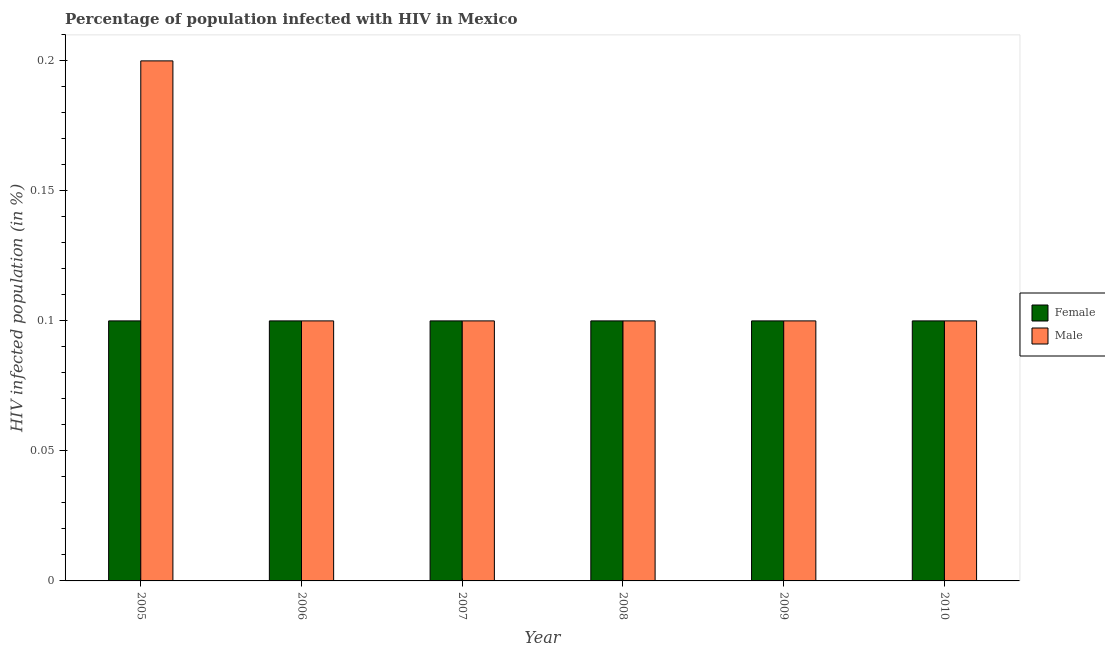How many different coloured bars are there?
Make the answer very short. 2. How many bars are there on the 5th tick from the right?
Your answer should be compact. 2. What is the label of the 6th group of bars from the left?
Ensure brevity in your answer.  2010. In how many cases, is the number of bars for a given year not equal to the number of legend labels?
Your answer should be compact. 0. What is the percentage of females who are infected with hiv in 2007?
Provide a succinct answer. 0.1. In which year was the percentage of females who are infected with hiv maximum?
Offer a terse response. 2005. In which year was the percentage of females who are infected with hiv minimum?
Offer a very short reply. 2005. What is the total percentage of males who are infected with hiv in the graph?
Offer a very short reply. 0.7. What is the difference between the percentage of females who are infected with hiv in 2008 and the percentage of males who are infected with hiv in 2009?
Ensure brevity in your answer.  0. What is the average percentage of females who are infected with hiv per year?
Provide a succinct answer. 0.1. Is the percentage of males who are infected with hiv in 2007 less than that in 2008?
Your response must be concise. No. Is the difference between the percentage of males who are infected with hiv in 2005 and 2006 greater than the difference between the percentage of females who are infected with hiv in 2005 and 2006?
Your answer should be very brief. No. What does the 2nd bar from the right in 2009 represents?
Give a very brief answer. Female. Does the graph contain any zero values?
Offer a very short reply. No. How many legend labels are there?
Offer a very short reply. 2. How are the legend labels stacked?
Your answer should be very brief. Vertical. What is the title of the graph?
Your answer should be very brief. Percentage of population infected with HIV in Mexico. What is the label or title of the Y-axis?
Provide a succinct answer. HIV infected population (in %). What is the HIV infected population (in %) of Female in 2005?
Keep it short and to the point. 0.1. What is the HIV infected population (in %) in Female in 2006?
Offer a very short reply. 0.1. What is the HIV infected population (in %) in Male in 2006?
Your answer should be compact. 0.1. What is the HIV infected population (in %) of Male in 2008?
Ensure brevity in your answer.  0.1. What is the HIV infected population (in %) of Female in 2010?
Offer a terse response. 0.1. Across all years, what is the maximum HIV infected population (in %) in Male?
Give a very brief answer. 0.2. Across all years, what is the minimum HIV infected population (in %) in Female?
Your response must be concise. 0.1. Across all years, what is the minimum HIV infected population (in %) in Male?
Your response must be concise. 0.1. What is the difference between the HIV infected population (in %) in Female in 2005 and that in 2006?
Provide a short and direct response. 0. What is the difference between the HIV infected population (in %) in Male in 2005 and that in 2008?
Ensure brevity in your answer.  0.1. What is the difference between the HIV infected population (in %) in Male in 2005 and that in 2010?
Keep it short and to the point. 0.1. What is the difference between the HIV infected population (in %) in Male in 2006 and that in 2007?
Provide a succinct answer. 0. What is the difference between the HIV infected population (in %) of Female in 2006 and that in 2008?
Ensure brevity in your answer.  0. What is the difference between the HIV infected population (in %) in Male in 2006 and that in 2008?
Your answer should be compact. 0. What is the difference between the HIV infected population (in %) of Female in 2006 and that in 2009?
Ensure brevity in your answer.  0. What is the difference between the HIV infected population (in %) of Male in 2007 and that in 2008?
Your answer should be compact. 0. What is the difference between the HIV infected population (in %) in Female in 2007 and that in 2009?
Provide a succinct answer. 0. What is the difference between the HIV infected population (in %) of Female in 2007 and that in 2010?
Offer a terse response. 0. What is the difference between the HIV infected population (in %) in Female in 2008 and that in 2009?
Provide a short and direct response. 0. What is the difference between the HIV infected population (in %) of Male in 2008 and that in 2009?
Your response must be concise. 0. What is the difference between the HIV infected population (in %) in Female in 2008 and that in 2010?
Give a very brief answer. 0. What is the difference between the HIV infected population (in %) of Female in 2005 and the HIV infected population (in %) of Male in 2006?
Give a very brief answer. 0. What is the difference between the HIV infected population (in %) of Female in 2005 and the HIV infected population (in %) of Male in 2008?
Your answer should be very brief. 0. What is the difference between the HIV infected population (in %) of Female in 2006 and the HIV infected population (in %) of Male in 2008?
Offer a terse response. 0. What is the difference between the HIV infected population (in %) of Female in 2006 and the HIV infected population (in %) of Male in 2009?
Your answer should be very brief. 0. What is the difference between the HIV infected population (in %) in Female in 2006 and the HIV infected population (in %) in Male in 2010?
Keep it short and to the point. 0. What is the difference between the HIV infected population (in %) of Female in 2007 and the HIV infected population (in %) of Male in 2008?
Offer a terse response. 0. What is the difference between the HIV infected population (in %) of Female in 2007 and the HIV infected population (in %) of Male in 2009?
Your answer should be very brief. 0. What is the difference between the HIV infected population (in %) in Female in 2007 and the HIV infected population (in %) in Male in 2010?
Your answer should be very brief. 0. What is the difference between the HIV infected population (in %) in Female in 2008 and the HIV infected population (in %) in Male in 2009?
Your answer should be very brief. 0. What is the difference between the HIV infected population (in %) of Female in 2008 and the HIV infected population (in %) of Male in 2010?
Provide a succinct answer. 0. What is the difference between the HIV infected population (in %) in Female in 2009 and the HIV infected population (in %) in Male in 2010?
Make the answer very short. 0. What is the average HIV infected population (in %) in Female per year?
Give a very brief answer. 0.1. What is the average HIV infected population (in %) of Male per year?
Provide a short and direct response. 0.12. In the year 2005, what is the difference between the HIV infected population (in %) of Female and HIV infected population (in %) of Male?
Make the answer very short. -0.1. In the year 2006, what is the difference between the HIV infected population (in %) in Female and HIV infected population (in %) in Male?
Your answer should be very brief. 0. In the year 2007, what is the difference between the HIV infected population (in %) in Female and HIV infected population (in %) in Male?
Your answer should be very brief. 0. What is the ratio of the HIV infected population (in %) of Female in 2005 to that in 2006?
Ensure brevity in your answer.  1. What is the ratio of the HIV infected population (in %) of Female in 2005 to that in 2007?
Provide a short and direct response. 1. What is the ratio of the HIV infected population (in %) of Female in 2005 to that in 2008?
Offer a very short reply. 1. What is the ratio of the HIV infected population (in %) in Male in 2005 to that in 2008?
Offer a very short reply. 2. What is the ratio of the HIV infected population (in %) in Male in 2005 to that in 2009?
Your answer should be very brief. 2. What is the ratio of the HIV infected population (in %) in Female in 2005 to that in 2010?
Provide a short and direct response. 1. What is the ratio of the HIV infected population (in %) in Male in 2005 to that in 2010?
Give a very brief answer. 2. What is the ratio of the HIV infected population (in %) of Female in 2006 to that in 2007?
Your response must be concise. 1. What is the ratio of the HIV infected population (in %) in Male in 2006 to that in 2007?
Ensure brevity in your answer.  1. What is the ratio of the HIV infected population (in %) of Female in 2006 to that in 2008?
Keep it short and to the point. 1. What is the ratio of the HIV infected population (in %) in Male in 2006 to that in 2008?
Make the answer very short. 1. What is the ratio of the HIV infected population (in %) in Male in 2006 to that in 2009?
Provide a short and direct response. 1. What is the ratio of the HIV infected population (in %) in Female in 2006 to that in 2010?
Make the answer very short. 1. What is the ratio of the HIV infected population (in %) of Male in 2006 to that in 2010?
Your answer should be very brief. 1. What is the ratio of the HIV infected population (in %) of Male in 2007 to that in 2009?
Your answer should be compact. 1. What is the ratio of the HIV infected population (in %) in Male in 2008 to that in 2009?
Provide a succinct answer. 1. What is the ratio of the HIV infected population (in %) in Male in 2008 to that in 2010?
Offer a terse response. 1. What is the ratio of the HIV infected population (in %) of Female in 2009 to that in 2010?
Give a very brief answer. 1. What is the ratio of the HIV infected population (in %) in Male in 2009 to that in 2010?
Ensure brevity in your answer.  1. What is the difference between the highest and the second highest HIV infected population (in %) in Female?
Your answer should be very brief. 0. What is the difference between the highest and the lowest HIV infected population (in %) of Female?
Make the answer very short. 0. 